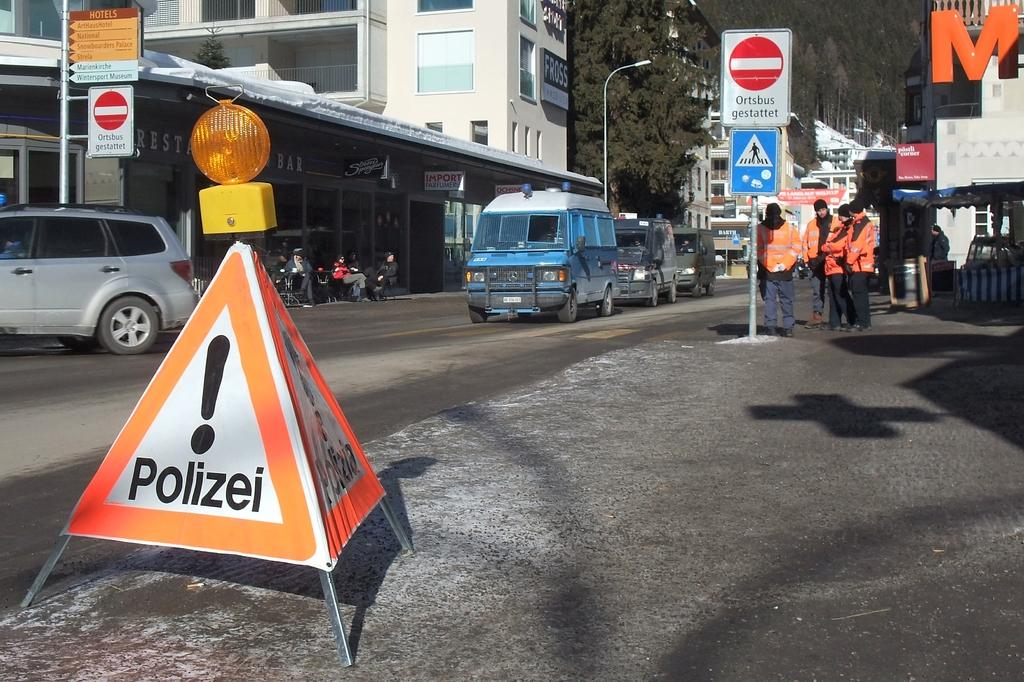<image>
Write a terse but informative summary of the picture. People standing next to a sign which says "Polizei" on it. 